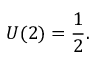<formula> <loc_0><loc_0><loc_500><loc_500>U ( 2 ) = { \frac { 1 } { 2 } } .</formula> 